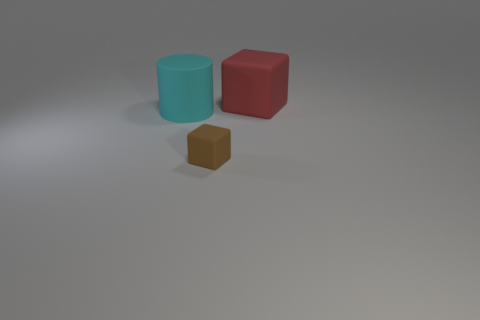Is there any other thing that has the same size as the brown object?
Make the answer very short. No. Are there fewer large cyan matte things on the left side of the brown block than brown objects?
Offer a very short reply. No. Do the matte cube behind the brown cube and the big cyan thing have the same size?
Ensure brevity in your answer.  Yes. How many matte cubes are both behind the tiny rubber block and in front of the big cylinder?
Offer a terse response. 0. How big is the rubber object that is to the right of the rubber object in front of the big rubber cylinder?
Keep it short and to the point. Large. Is the number of large red cubes to the left of the large cyan matte cylinder less than the number of small cubes in front of the tiny brown rubber cube?
Provide a succinct answer. No. There is a matte thing that is on the left side of the small brown rubber block; is it the same color as the large object behind the big cyan cylinder?
Offer a very short reply. No. What is the thing that is behind the small rubber object and in front of the red matte object made of?
Your answer should be very brief. Rubber. Is there a big red rubber sphere?
Your response must be concise. No. There is a big cyan object that is made of the same material as the small thing; what shape is it?
Ensure brevity in your answer.  Cylinder. 